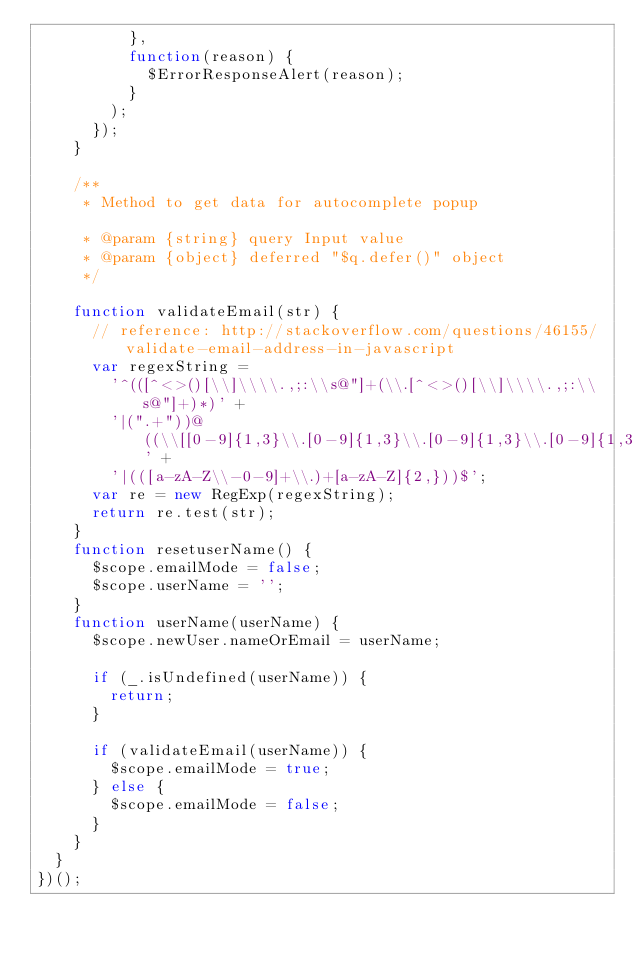Convert code to text. <code><loc_0><loc_0><loc_500><loc_500><_JavaScript_>          },
          function(reason) {
            $ErrorResponseAlert(reason);
          }
        );
      });
    }

    /**
     * Method to get data for autocomplete popup

     * @param {string} query Input value
     * @param {object} deferred "$q.defer()" object
     */

    function validateEmail(str) {
      // reference: http://stackoverflow.com/questions/46155/validate-email-address-in-javascript
      var regexString =
        '^(([^<>()[\\]\\\\.,;:\\s@"]+(\\.[^<>()[\\]\\\\.,;:\\s@"]+)*)' +
        '|(".+"))@((\\[[0-9]{1,3}\\.[0-9]{1,3}\\.[0-9]{1,3}\\.[0-9]{1,3}])' +
        '|(([a-zA-Z\\-0-9]+\\.)+[a-zA-Z]{2,}))$';
      var re = new RegExp(regexString);
      return re.test(str);
    }
    function resetuserName() {
      $scope.emailMode = false;
      $scope.userName = '';
    }
    function userName(userName) {
      $scope.newUser.nameOrEmail = userName;

      if (_.isUndefined(userName)) {
        return;
      }

      if (validateEmail(userName)) {
        $scope.emailMode = true;
      } else {
        $scope.emailMode = false;
      }
    }
  }
})();
</code> 